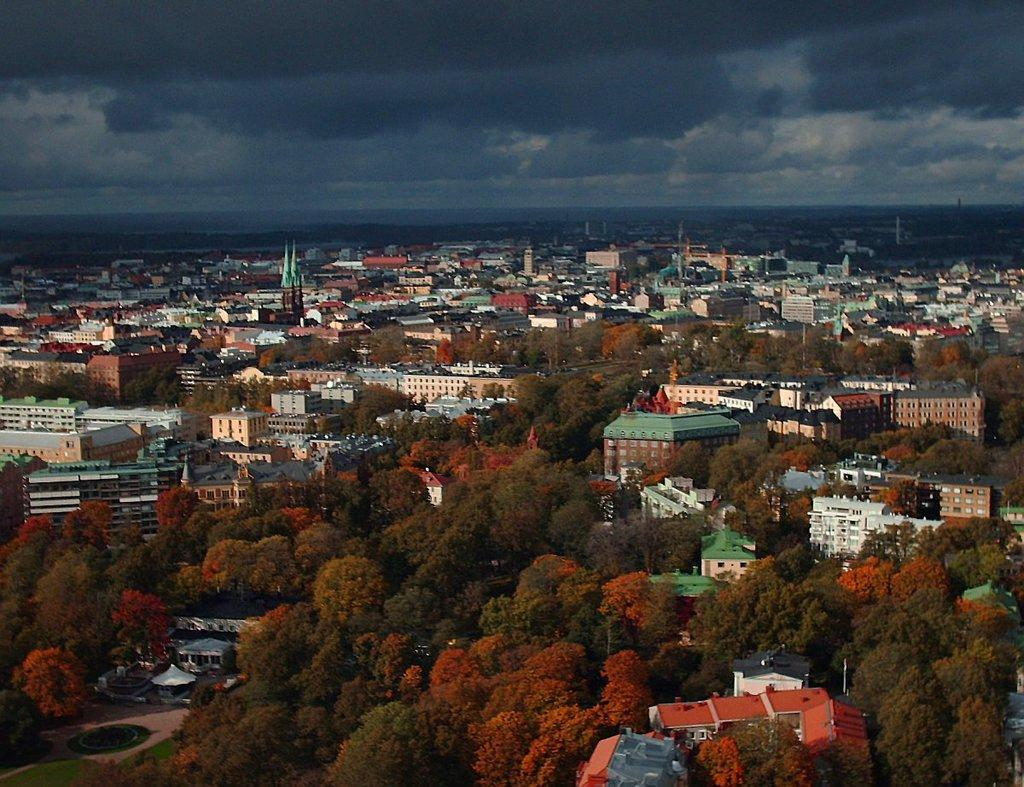What perspective is used in the image? The image provides a top view of the city. What can be seen in the front of the image? There are many houses and trees visible in the front of the image. What is visible at the top of the image? The sky is visible at the top of the image. What can be observed in the sky? Clouds are present in the sky. What position does the class take in the image? There is no class present in the image; it shows a top view of a city with houses, trees, and clouds. Where is the best spot to view the entire city in the image? The image itself provides a top view of the city, so there is no need to find a specific spot to view the entire city. 